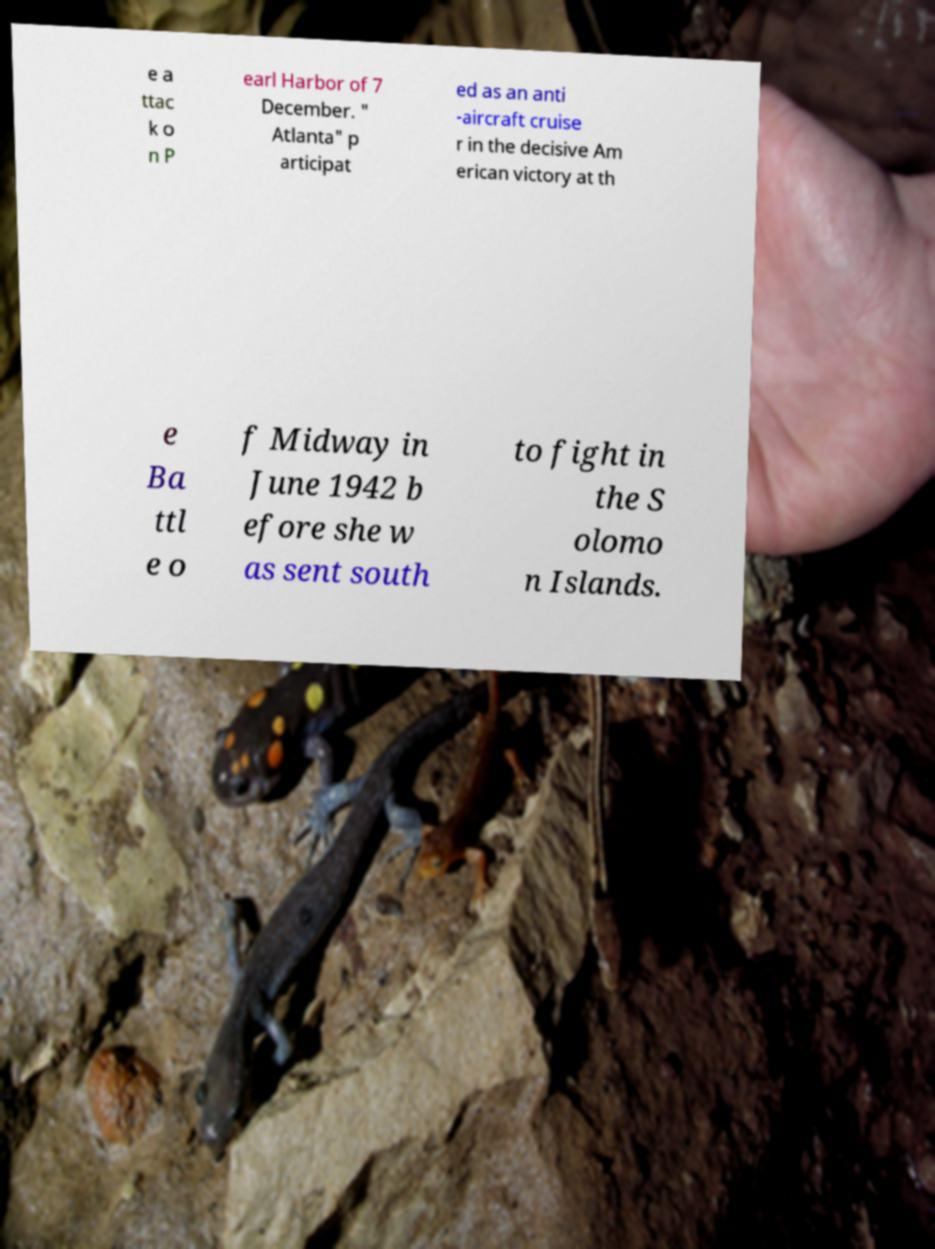Please read and relay the text visible in this image. What does it say? e a ttac k o n P earl Harbor of 7 December. " Atlanta" p articipat ed as an anti -aircraft cruise r in the decisive Am erican victory at th e Ba ttl e o f Midway in June 1942 b efore she w as sent south to fight in the S olomo n Islands. 